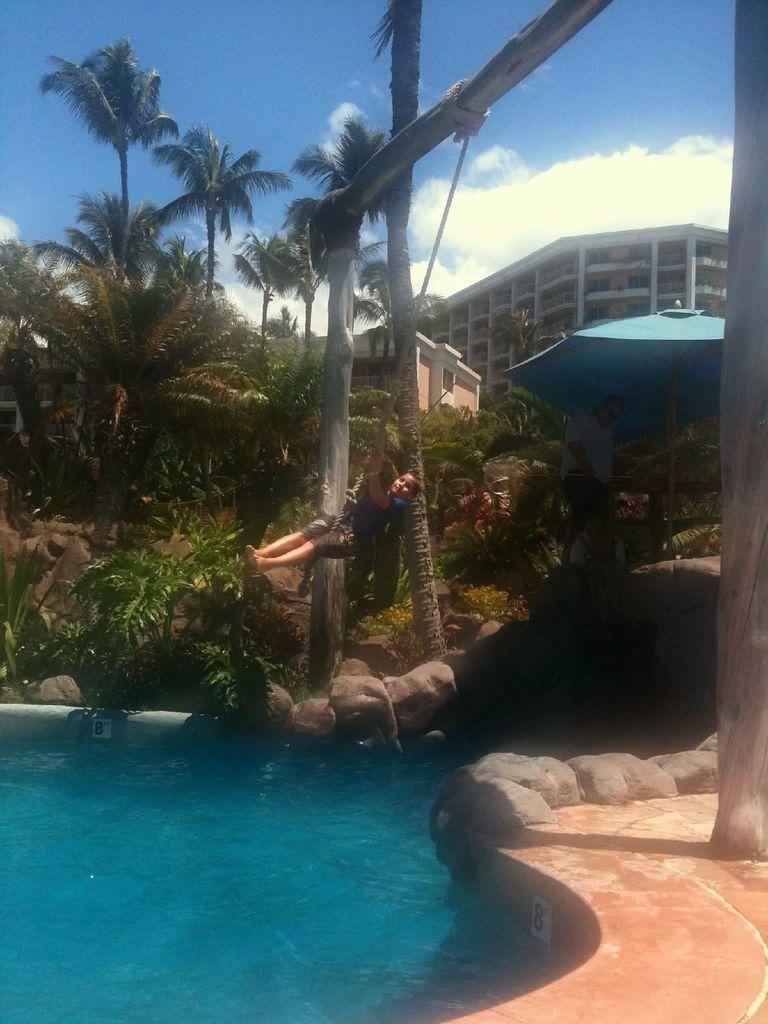Could you give a brief overview of what you see in this image? In this image we can see a swimming pool, there is a person hanging with the help of a rope, which is tied to the poles, across the pool there are some trees, rocks, plants, there are buildings, and an umbrella, also we can see the sky. 